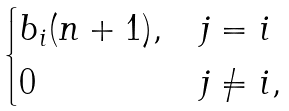<formula> <loc_0><loc_0><loc_500><loc_500>\begin{cases} b _ { i } ( n + 1 ) , & j = i \\ 0 & j \neq i , \end{cases}</formula> 